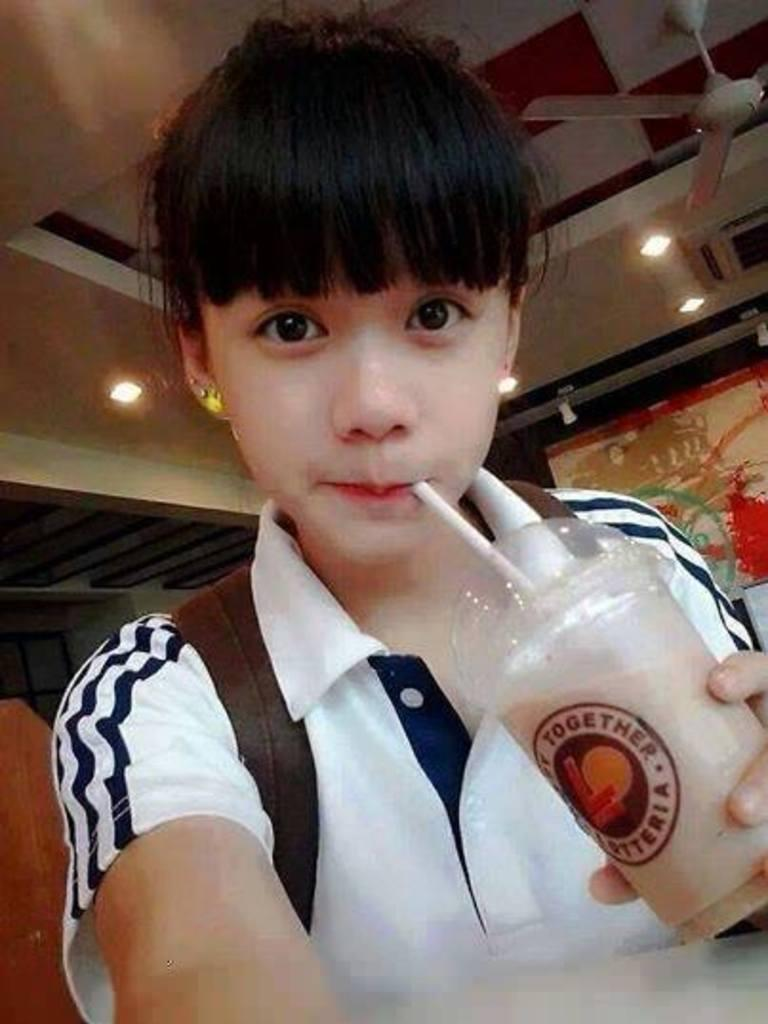What is the girl in the image doing? The girl is sitting in the image. What is the girl holding in the image? The girl is holding an object. What can be seen in the background of the image? There is a fan and lights visible in the image. What type of dust can be seen attacking the girl in the image? There is no dust or attack present in the image; the girl is simply sitting and holding an object. 